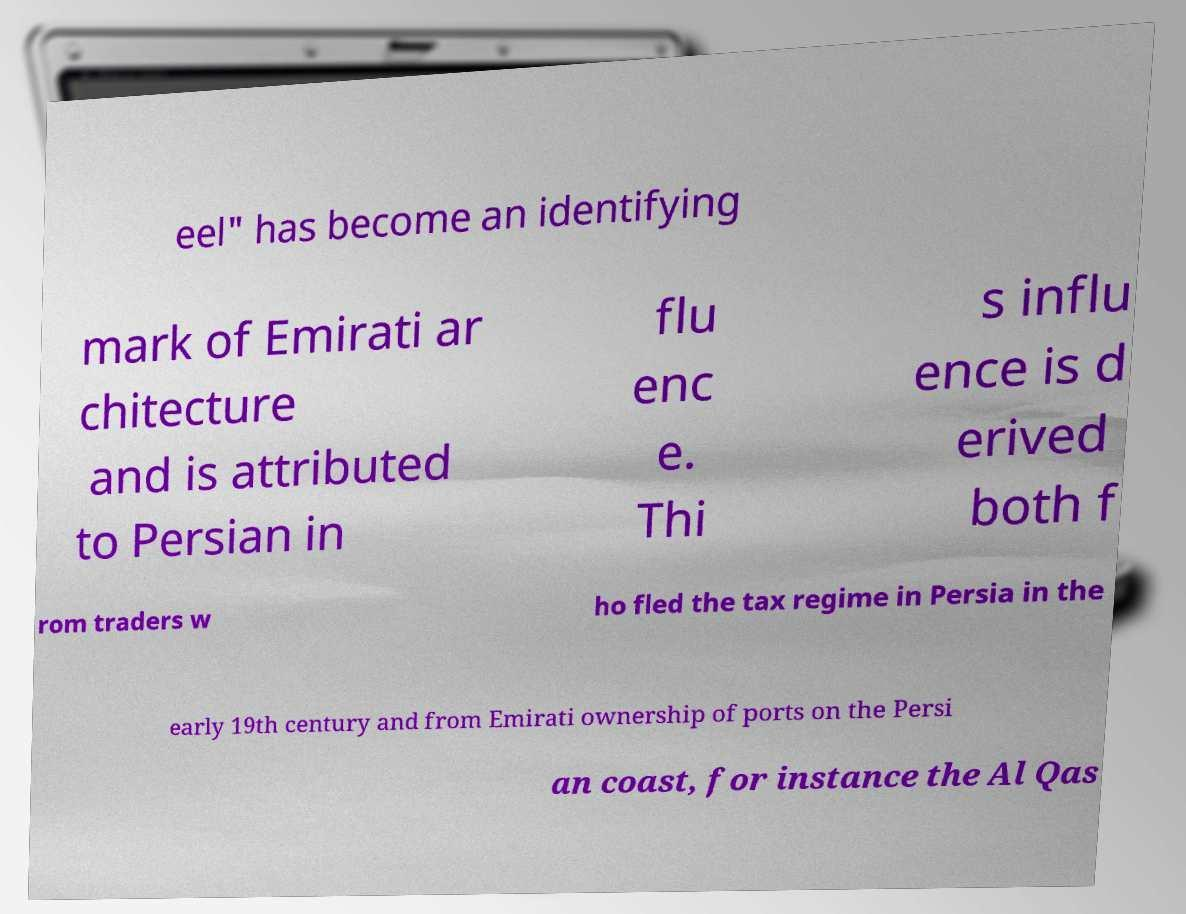Can you accurately transcribe the text from the provided image for me? eel" has become an identifying mark of Emirati ar chitecture and is attributed to Persian in flu enc e. Thi s influ ence is d erived both f rom traders w ho fled the tax regime in Persia in the early 19th century and from Emirati ownership of ports on the Persi an coast, for instance the Al Qas 